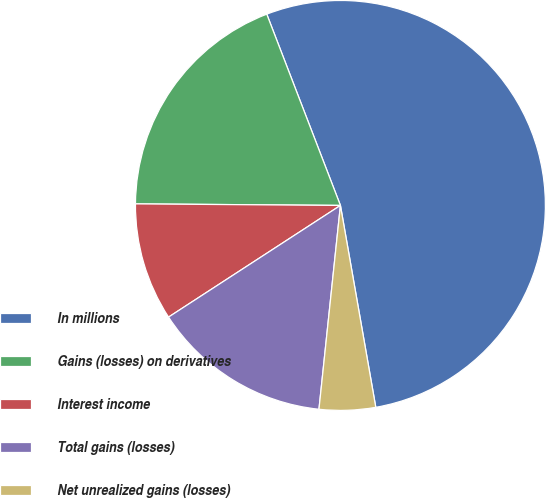Convert chart to OTSL. <chart><loc_0><loc_0><loc_500><loc_500><pie_chart><fcel>In millions<fcel>Gains (losses) on derivatives<fcel>Interest income<fcel>Total gains (losses)<fcel>Net unrealized gains (losses)<nl><fcel>53.09%<fcel>19.03%<fcel>9.29%<fcel>14.16%<fcel>4.43%<nl></chart> 